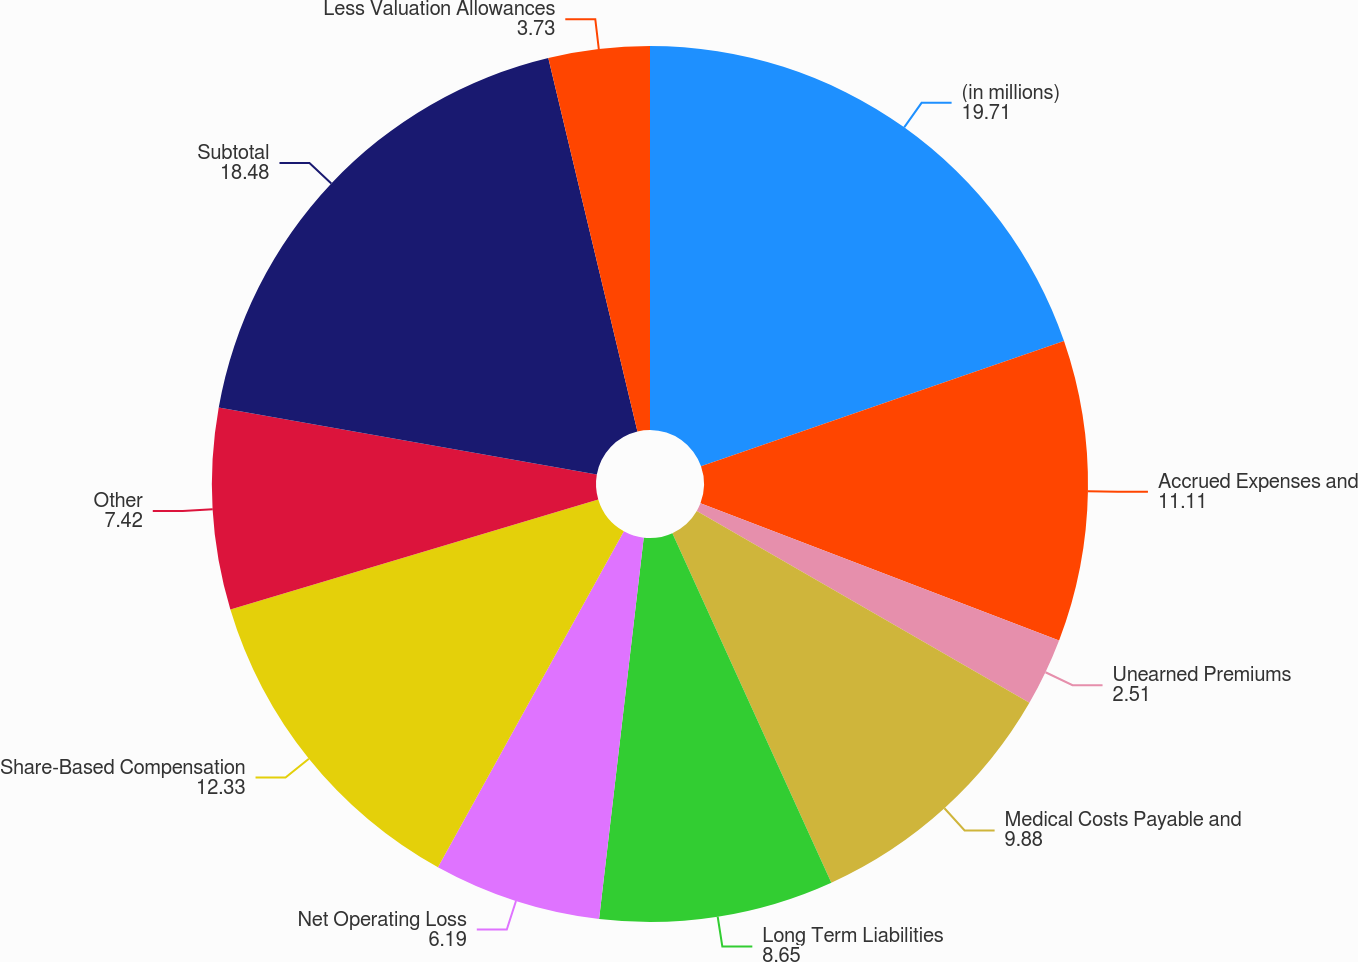Convert chart. <chart><loc_0><loc_0><loc_500><loc_500><pie_chart><fcel>(in millions)<fcel>Accrued Expenses and<fcel>Unearned Premiums<fcel>Medical Costs Payable and<fcel>Long Term Liabilities<fcel>Net Operating Loss<fcel>Share-Based Compensation<fcel>Other<fcel>Subtotal<fcel>Less Valuation Allowances<nl><fcel>19.71%<fcel>11.11%<fcel>2.51%<fcel>9.88%<fcel>8.65%<fcel>6.19%<fcel>12.33%<fcel>7.42%<fcel>18.48%<fcel>3.73%<nl></chart> 